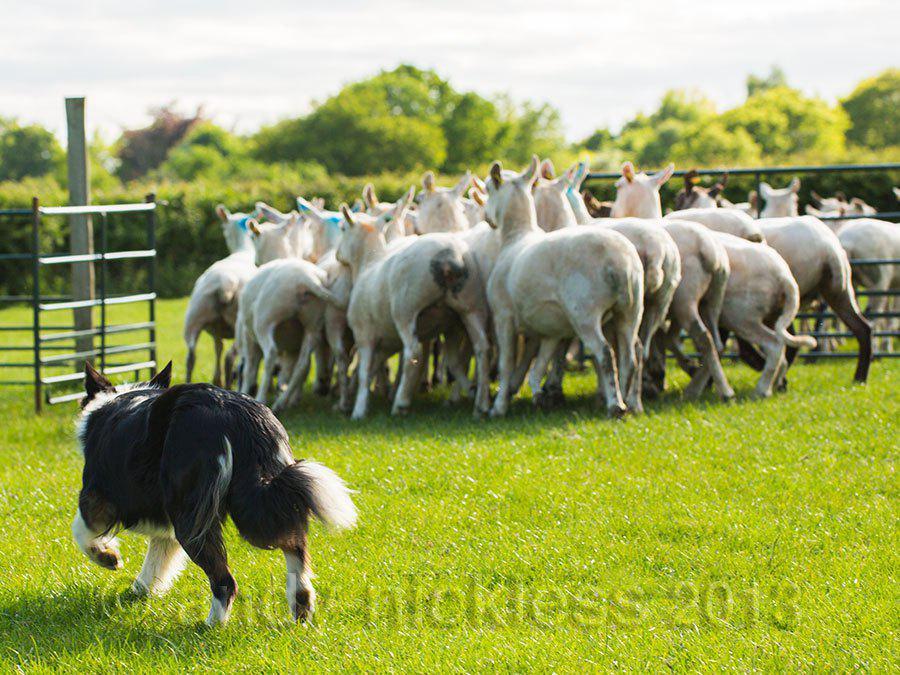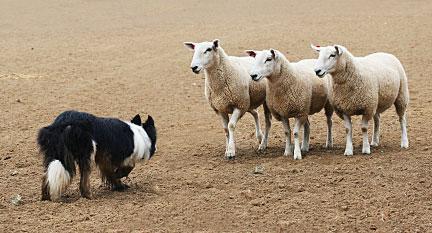The first image is the image on the left, the second image is the image on the right. Assess this claim about the two images: "The dog is facing the animals in one of the pictures.". Correct or not? Answer yes or no. Yes. The first image is the image on the left, the second image is the image on the right. Analyze the images presented: Is the assertion "An image shows a sheepdog with 3 sheep." valid? Answer yes or no. Yes. 